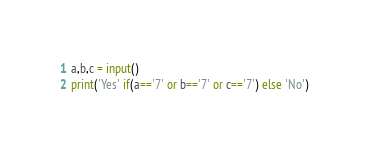<code> <loc_0><loc_0><loc_500><loc_500><_Python_>a,b,c = input()
print('Yes' if(a=='7' or b=='7' or c=='7') else 'No')</code> 